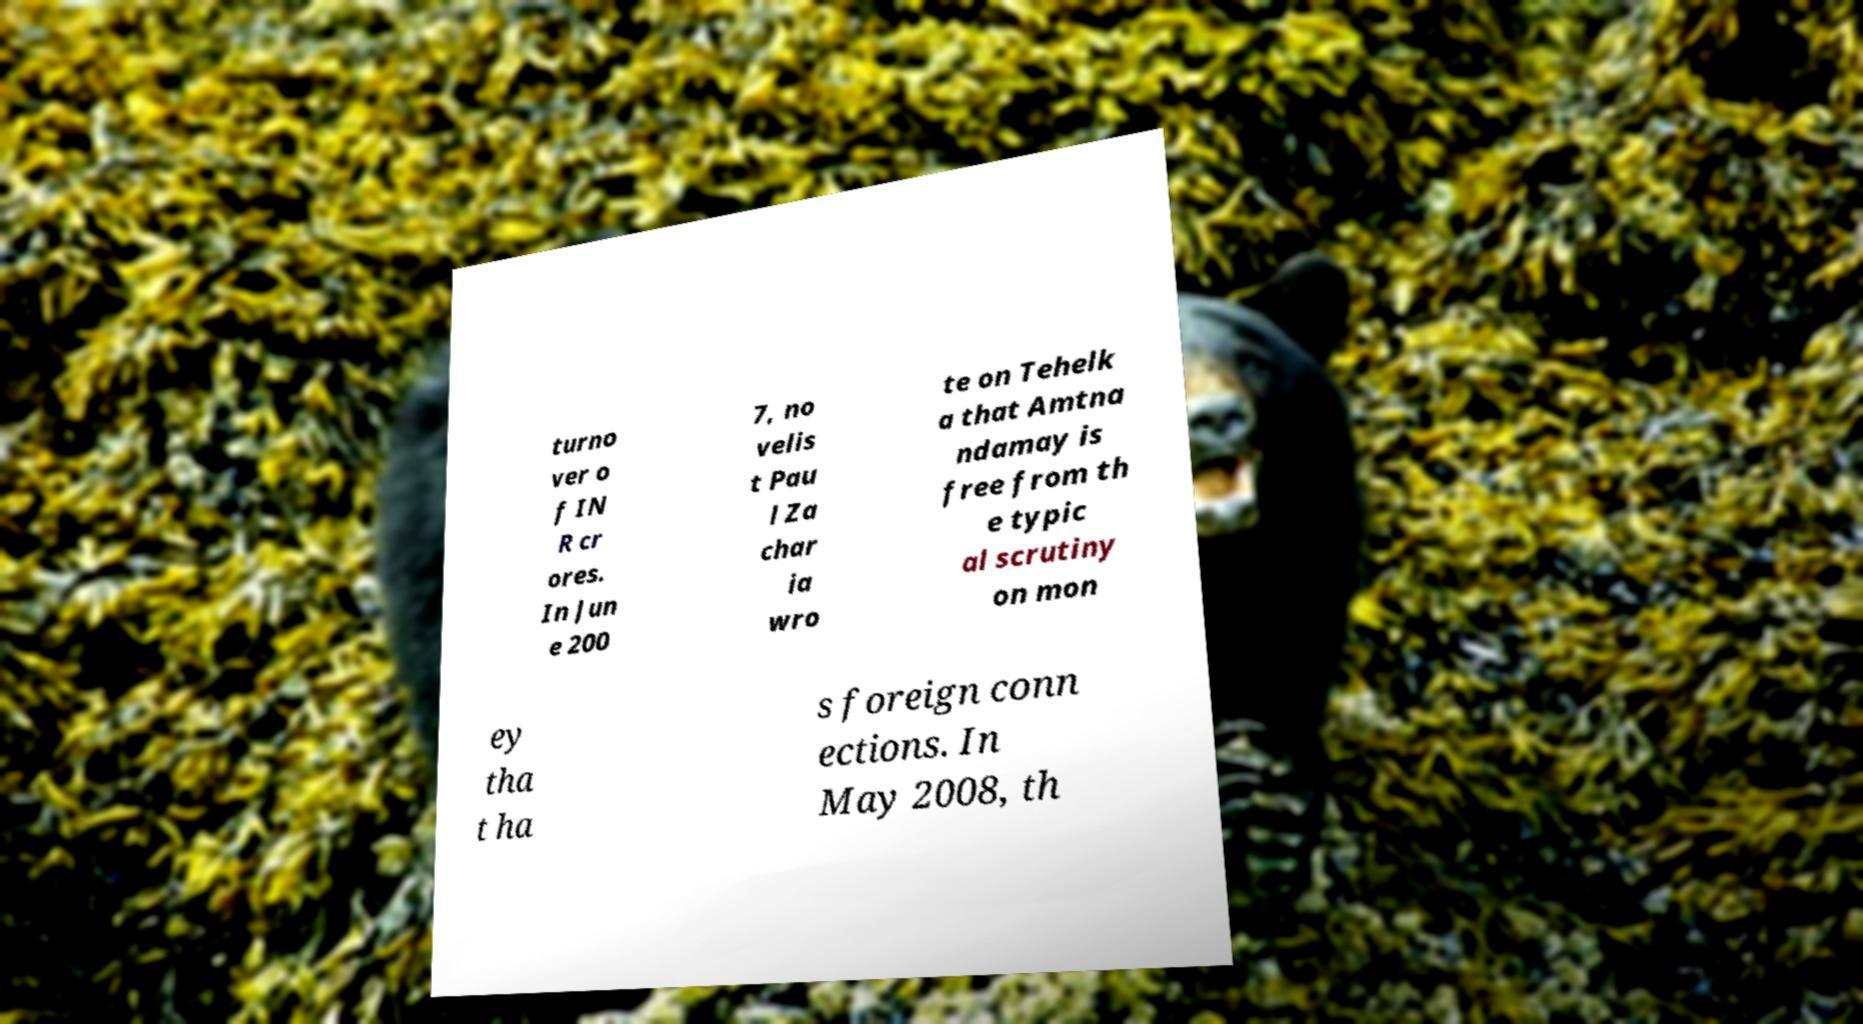What messages or text are displayed in this image? I need them in a readable, typed format. turno ver o f IN R cr ores. In Jun e 200 7, no velis t Pau l Za char ia wro te on Tehelk a that Amtna ndamay is free from th e typic al scrutiny on mon ey tha t ha s foreign conn ections. In May 2008, th 